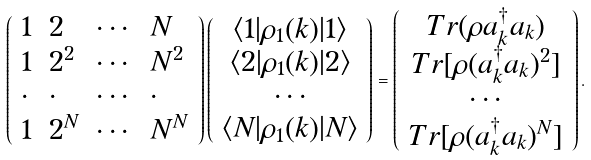<formula> <loc_0><loc_0><loc_500><loc_500>\left ( \begin{array} { l l l l } 1 & 2 & \cdots & N \\ 1 & 2 ^ { 2 } & \cdots & N ^ { 2 } \\ \cdot & \cdot & \cdots & \cdot \\ 1 & 2 ^ { N } & \cdots & N ^ { N } \end{array} \right ) \left ( \begin{array} { c } \langle 1 | \rho _ { 1 } ( k ) | 1 \rangle \\ \langle 2 | \rho _ { 1 } ( k ) | 2 \rangle \\ \cdots \\ \langle N | \rho _ { 1 } ( k ) | N \rangle \end{array} \right ) = \left ( \begin{array} { c } T r ( \rho a _ { k } ^ { \dagger } a _ { k } ) \\ T r [ \rho ( a _ { k } ^ { \dagger } a _ { k } ) ^ { 2 } ] \\ \cdots \\ T r [ \rho ( a _ { k } ^ { \dagger } a _ { k } ) ^ { N } ] \end{array} \right ) .</formula> 